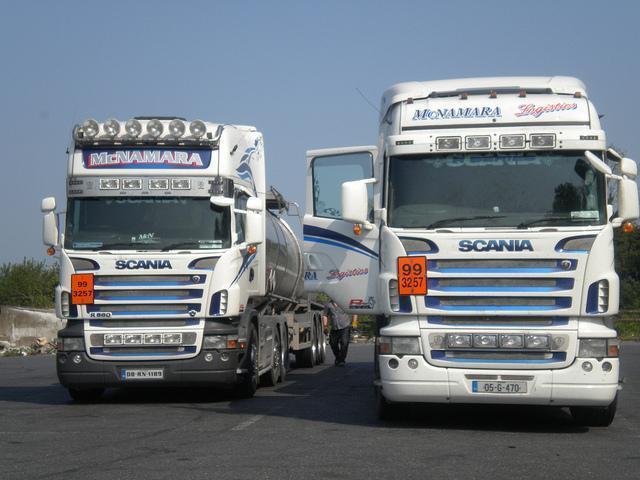How many trucks are there?
Give a very brief answer. 2. How many people are shown?
Give a very brief answer. 1. How many lights are above the windshield?
Give a very brief answer. 4. How many trucks are in the photo?
Give a very brief answer. 2. 